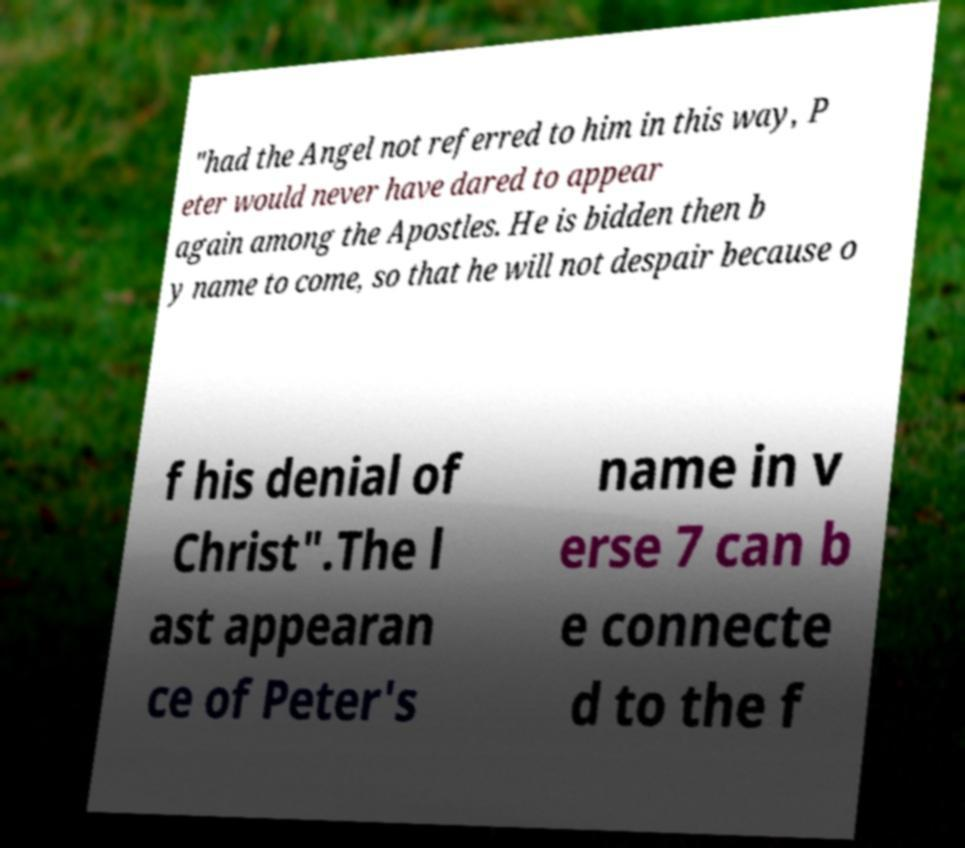I need the written content from this picture converted into text. Can you do that? "had the Angel not referred to him in this way, P eter would never have dared to appear again among the Apostles. He is bidden then b y name to come, so that he will not despair because o f his denial of Christ".The l ast appearan ce of Peter's name in v erse 7 can b e connecte d to the f 